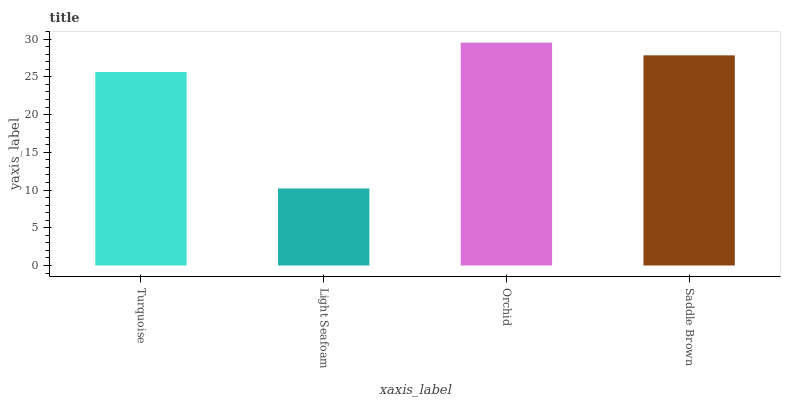Is Light Seafoam the minimum?
Answer yes or no. Yes. Is Orchid the maximum?
Answer yes or no. Yes. Is Orchid the minimum?
Answer yes or no. No. Is Light Seafoam the maximum?
Answer yes or no. No. Is Orchid greater than Light Seafoam?
Answer yes or no. Yes. Is Light Seafoam less than Orchid?
Answer yes or no. Yes. Is Light Seafoam greater than Orchid?
Answer yes or no. No. Is Orchid less than Light Seafoam?
Answer yes or no. No. Is Saddle Brown the high median?
Answer yes or no. Yes. Is Turquoise the low median?
Answer yes or no. Yes. Is Orchid the high median?
Answer yes or no. No. Is Saddle Brown the low median?
Answer yes or no. No. 